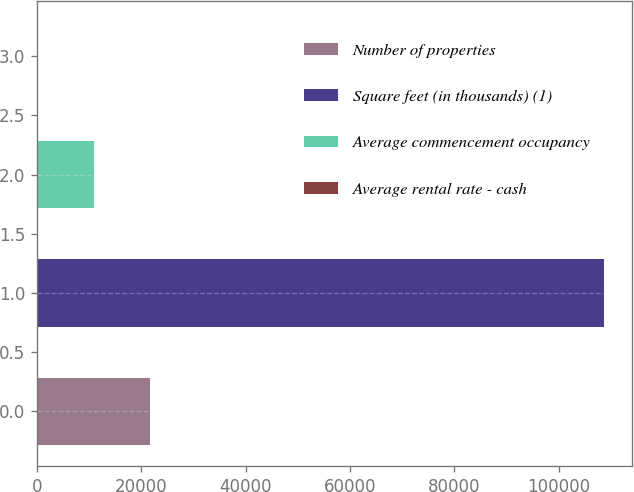<chart> <loc_0><loc_0><loc_500><loc_500><bar_chart><fcel>Number of properties<fcel>Square feet (in thousands) (1)<fcel>Average commencement occupancy<fcel>Average rental rate - cash<nl><fcel>21724.7<fcel>108604<fcel>10864.8<fcel>4.9<nl></chart> 